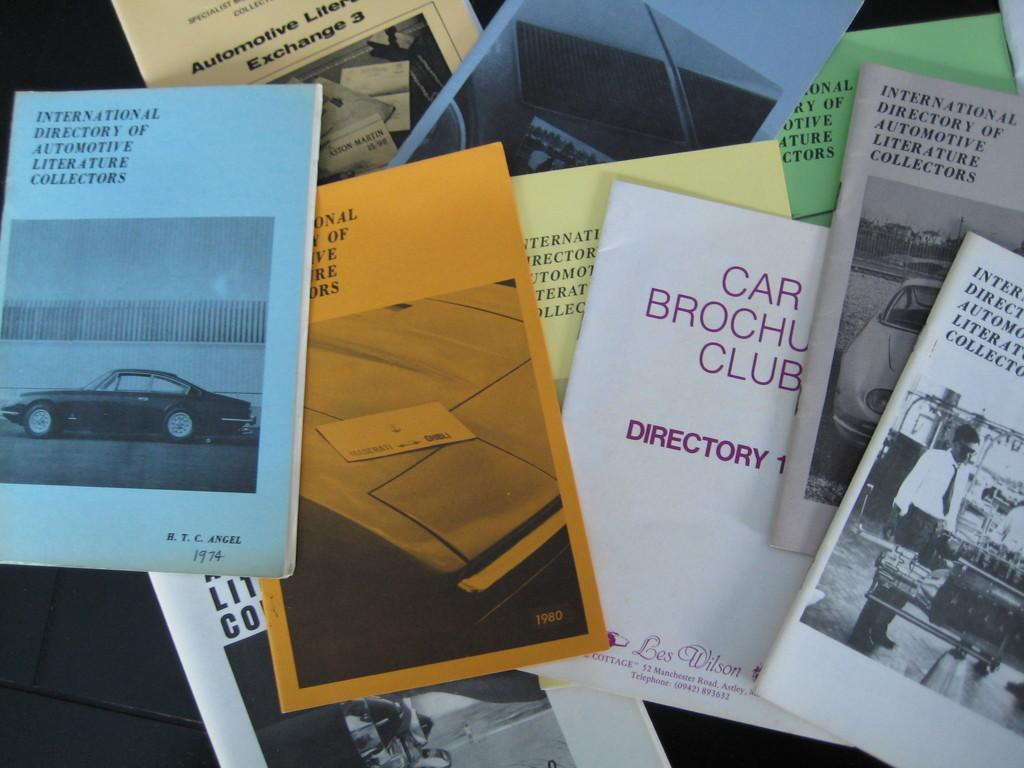<image>
Create a compact narrative representing the image presented. A stack of brochures for the Car Brochure Club. 